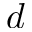<formula> <loc_0><loc_0><loc_500><loc_500>d</formula> 